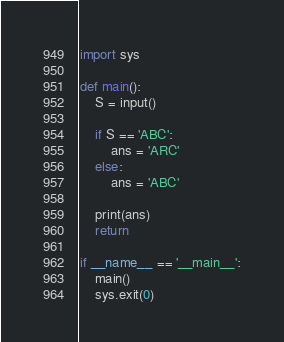<code> <loc_0><loc_0><loc_500><loc_500><_Python_>import sys

def main():
    S = input()

    if S == 'ABC':
        ans = 'ARC'
    else:
        ans = 'ABC'

    print(ans)
    return

if __name__ == '__main__':
    main()
    sys.exit(0)</code> 